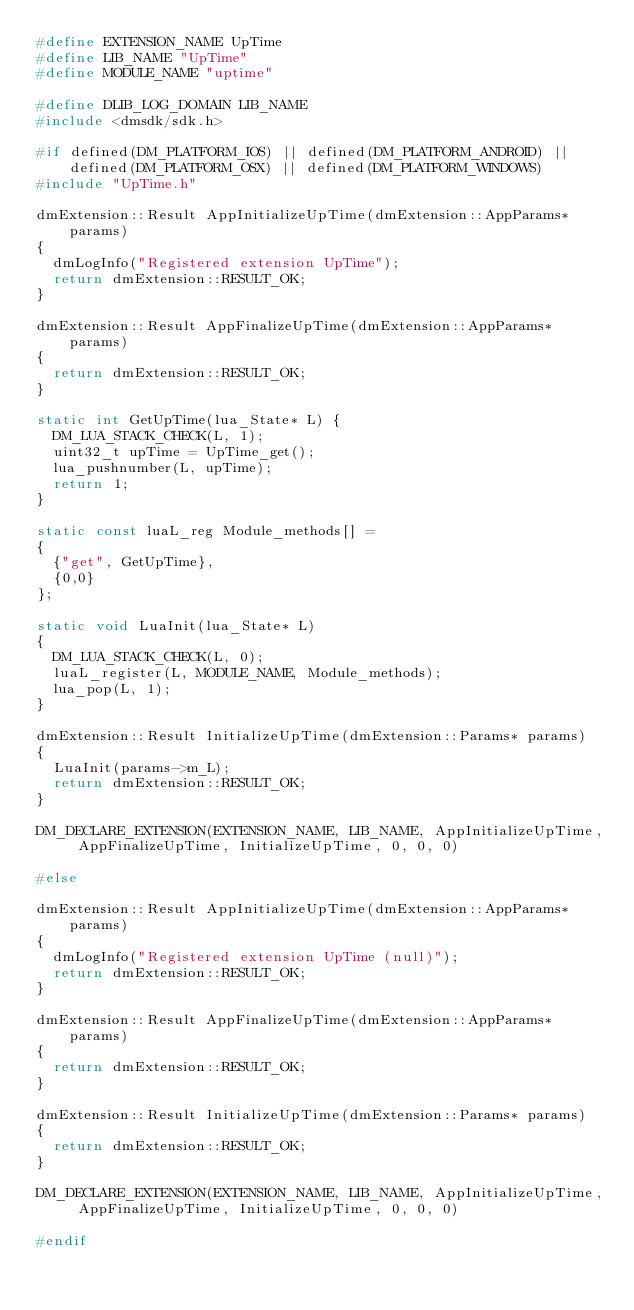Convert code to text. <code><loc_0><loc_0><loc_500><loc_500><_C++_>#define EXTENSION_NAME UpTime
#define LIB_NAME "UpTime"
#define MODULE_NAME "uptime"

#define DLIB_LOG_DOMAIN LIB_NAME
#include <dmsdk/sdk.h>

#if defined(DM_PLATFORM_IOS) || defined(DM_PLATFORM_ANDROID) || defined(DM_PLATFORM_OSX) || defined(DM_PLATFORM_WINDOWS)
#include "UpTime.h"

dmExtension::Result AppInitializeUpTime(dmExtension::AppParams* params)
{
  dmLogInfo("Registered extension UpTime");
  return dmExtension::RESULT_OK;
}

dmExtension::Result AppFinalizeUpTime(dmExtension::AppParams* params)
{
  return dmExtension::RESULT_OK;
}

static int GetUpTime(lua_State* L) {
  DM_LUA_STACK_CHECK(L, 1);
  uint32_t upTime = UpTime_get();
  lua_pushnumber(L, upTime);
  return 1;
}

static const luaL_reg Module_methods[] =
{
  {"get", GetUpTime},
  {0,0}
};

static void LuaInit(lua_State* L)
{
  DM_LUA_STACK_CHECK(L, 0);
  luaL_register(L, MODULE_NAME, Module_methods);
  lua_pop(L, 1);
}

dmExtension::Result InitializeUpTime(dmExtension::Params* params)
{
  LuaInit(params->m_L);
  return dmExtension::RESULT_OK;
}

DM_DECLARE_EXTENSION(EXTENSION_NAME, LIB_NAME, AppInitializeUpTime, AppFinalizeUpTime, InitializeUpTime, 0, 0, 0)

#else

dmExtension::Result AppInitializeUpTime(dmExtension::AppParams* params)
{
  dmLogInfo("Registered extension UpTime (null)");
  return dmExtension::RESULT_OK;
}

dmExtension::Result AppFinalizeUpTime(dmExtension::AppParams* params)
{
  return dmExtension::RESULT_OK;
}

dmExtension::Result InitializeUpTime(dmExtension::Params* params)
{
  return dmExtension::RESULT_OK;
}

DM_DECLARE_EXTENSION(EXTENSION_NAME, LIB_NAME, AppInitializeUpTime, AppFinalizeUpTime, InitializeUpTime, 0, 0, 0)

#endif
</code> 